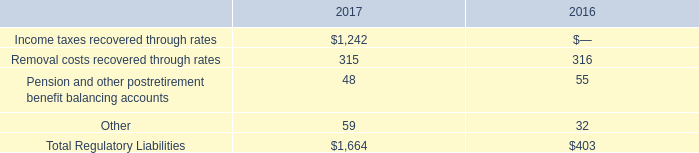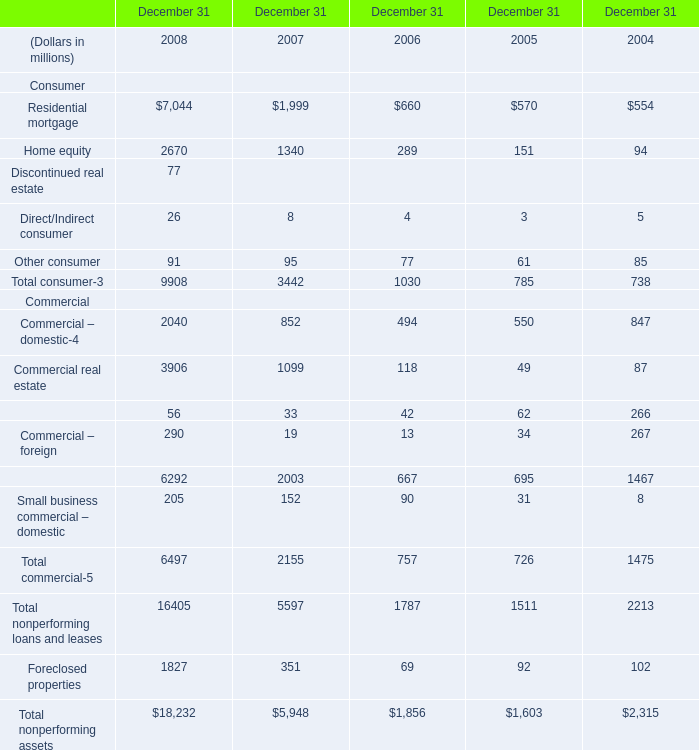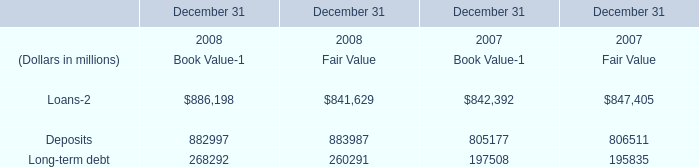What is the sum of Loans of December 31 2007 Fair Value, and Foreclosed properties Commercial of December 31 2008 ? 
Computations: (847405.0 + 1827.0)
Answer: 849232.0. 